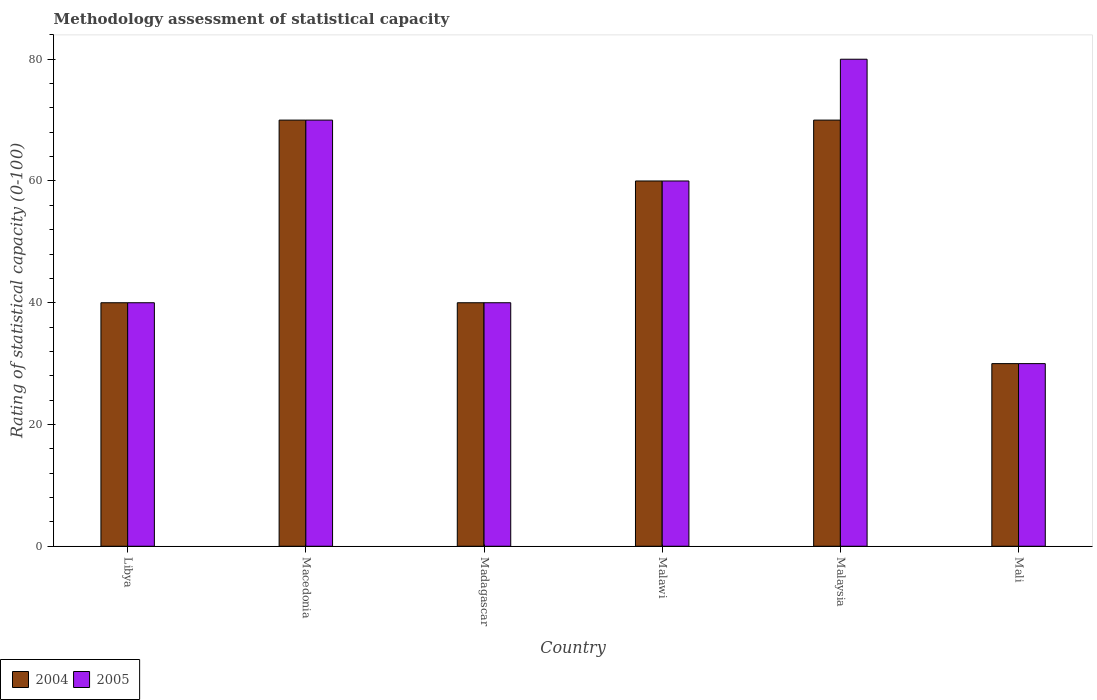How many different coloured bars are there?
Your answer should be very brief. 2. How many groups of bars are there?
Keep it short and to the point. 6. Are the number of bars on each tick of the X-axis equal?
Provide a short and direct response. Yes. What is the label of the 3rd group of bars from the left?
Offer a very short reply. Madagascar. In how many cases, is the number of bars for a given country not equal to the number of legend labels?
Make the answer very short. 0. What is the rating of statistical capacity in 2005 in Libya?
Keep it short and to the point. 40. Across all countries, what is the maximum rating of statistical capacity in 2004?
Your answer should be very brief. 70. In which country was the rating of statistical capacity in 2005 maximum?
Offer a very short reply. Malaysia. In which country was the rating of statistical capacity in 2004 minimum?
Your answer should be compact. Mali. What is the total rating of statistical capacity in 2004 in the graph?
Offer a terse response. 310. What is the difference between the rating of statistical capacity in 2004 in Libya and that in Malaysia?
Give a very brief answer. -30. What is the average rating of statistical capacity in 2004 per country?
Provide a short and direct response. 51.67. What is the difference between the rating of statistical capacity of/in 2004 and rating of statistical capacity of/in 2005 in Malawi?
Your answer should be compact. 0. In how many countries, is the rating of statistical capacity in 2004 greater than 56?
Provide a short and direct response. 3. What is the difference between the highest and the lowest rating of statistical capacity in 2004?
Your answer should be very brief. 40. What does the 2nd bar from the left in Libya represents?
Ensure brevity in your answer.  2005. What does the 1st bar from the right in Macedonia represents?
Your answer should be compact. 2005. Are all the bars in the graph horizontal?
Make the answer very short. No. What is the difference between two consecutive major ticks on the Y-axis?
Give a very brief answer. 20. What is the title of the graph?
Give a very brief answer. Methodology assessment of statistical capacity. Does "2012" appear as one of the legend labels in the graph?
Your response must be concise. No. What is the label or title of the X-axis?
Give a very brief answer. Country. What is the label or title of the Y-axis?
Provide a succinct answer. Rating of statistical capacity (0-100). What is the Rating of statistical capacity (0-100) of 2005 in Libya?
Make the answer very short. 40. What is the Rating of statistical capacity (0-100) of 2004 in Macedonia?
Your answer should be very brief. 70. What is the Rating of statistical capacity (0-100) in 2004 in Madagascar?
Give a very brief answer. 40. What is the Rating of statistical capacity (0-100) of 2005 in Madagascar?
Provide a succinct answer. 40. What is the Rating of statistical capacity (0-100) in 2004 in Malawi?
Your response must be concise. 60. What is the Rating of statistical capacity (0-100) in 2005 in Malawi?
Make the answer very short. 60. What is the Rating of statistical capacity (0-100) in 2004 in Mali?
Offer a terse response. 30. Across all countries, what is the maximum Rating of statistical capacity (0-100) in 2004?
Keep it short and to the point. 70. Across all countries, what is the minimum Rating of statistical capacity (0-100) of 2005?
Offer a very short reply. 30. What is the total Rating of statistical capacity (0-100) of 2004 in the graph?
Provide a short and direct response. 310. What is the total Rating of statistical capacity (0-100) in 2005 in the graph?
Offer a very short reply. 320. What is the difference between the Rating of statistical capacity (0-100) in 2004 in Libya and that in Madagascar?
Your answer should be compact. 0. What is the difference between the Rating of statistical capacity (0-100) in 2004 in Libya and that in Malawi?
Ensure brevity in your answer.  -20. What is the difference between the Rating of statistical capacity (0-100) of 2005 in Libya and that in Malawi?
Give a very brief answer. -20. What is the difference between the Rating of statistical capacity (0-100) in 2005 in Libya and that in Mali?
Your answer should be compact. 10. What is the difference between the Rating of statistical capacity (0-100) in 2004 in Macedonia and that in Madagascar?
Make the answer very short. 30. What is the difference between the Rating of statistical capacity (0-100) in 2005 in Macedonia and that in Madagascar?
Keep it short and to the point. 30. What is the difference between the Rating of statistical capacity (0-100) in 2004 in Macedonia and that in Malawi?
Provide a short and direct response. 10. What is the difference between the Rating of statistical capacity (0-100) of 2005 in Macedonia and that in Malawi?
Give a very brief answer. 10. What is the difference between the Rating of statistical capacity (0-100) of 2004 in Macedonia and that in Malaysia?
Ensure brevity in your answer.  0. What is the difference between the Rating of statistical capacity (0-100) of 2005 in Macedonia and that in Malaysia?
Give a very brief answer. -10. What is the difference between the Rating of statistical capacity (0-100) of 2004 in Macedonia and that in Mali?
Offer a terse response. 40. What is the difference between the Rating of statistical capacity (0-100) of 2005 in Macedonia and that in Mali?
Your response must be concise. 40. What is the difference between the Rating of statistical capacity (0-100) in 2004 in Madagascar and that in Malawi?
Your response must be concise. -20. What is the difference between the Rating of statistical capacity (0-100) in 2004 in Madagascar and that in Malaysia?
Your answer should be compact. -30. What is the difference between the Rating of statistical capacity (0-100) in 2004 in Malawi and that in Malaysia?
Offer a terse response. -10. What is the difference between the Rating of statistical capacity (0-100) of 2005 in Malawi and that in Malaysia?
Make the answer very short. -20. What is the difference between the Rating of statistical capacity (0-100) of 2005 in Malawi and that in Mali?
Ensure brevity in your answer.  30. What is the difference between the Rating of statistical capacity (0-100) in 2004 in Malaysia and that in Mali?
Give a very brief answer. 40. What is the difference between the Rating of statistical capacity (0-100) in 2004 in Macedonia and the Rating of statistical capacity (0-100) in 2005 in Madagascar?
Give a very brief answer. 30. What is the difference between the Rating of statistical capacity (0-100) in 2004 in Macedonia and the Rating of statistical capacity (0-100) in 2005 in Malawi?
Offer a very short reply. 10. What is the difference between the Rating of statistical capacity (0-100) in 2004 in Malawi and the Rating of statistical capacity (0-100) in 2005 in Mali?
Your response must be concise. 30. What is the average Rating of statistical capacity (0-100) in 2004 per country?
Ensure brevity in your answer.  51.67. What is the average Rating of statistical capacity (0-100) of 2005 per country?
Ensure brevity in your answer.  53.33. What is the difference between the Rating of statistical capacity (0-100) in 2004 and Rating of statistical capacity (0-100) in 2005 in Macedonia?
Provide a short and direct response. 0. What is the difference between the Rating of statistical capacity (0-100) of 2004 and Rating of statistical capacity (0-100) of 2005 in Malawi?
Your response must be concise. 0. What is the difference between the Rating of statistical capacity (0-100) of 2004 and Rating of statistical capacity (0-100) of 2005 in Mali?
Your answer should be very brief. 0. What is the ratio of the Rating of statistical capacity (0-100) in 2004 in Libya to that in Macedonia?
Offer a terse response. 0.57. What is the ratio of the Rating of statistical capacity (0-100) in 2005 in Libya to that in Macedonia?
Your answer should be compact. 0.57. What is the ratio of the Rating of statistical capacity (0-100) of 2005 in Libya to that in Madagascar?
Keep it short and to the point. 1. What is the ratio of the Rating of statistical capacity (0-100) of 2004 in Libya to that in Malawi?
Your answer should be compact. 0.67. What is the ratio of the Rating of statistical capacity (0-100) in 2005 in Libya to that in Malawi?
Provide a succinct answer. 0.67. What is the ratio of the Rating of statistical capacity (0-100) of 2004 in Libya to that in Malaysia?
Provide a succinct answer. 0.57. What is the ratio of the Rating of statistical capacity (0-100) of 2005 in Libya to that in Mali?
Ensure brevity in your answer.  1.33. What is the ratio of the Rating of statistical capacity (0-100) in 2004 in Macedonia to that in Madagascar?
Keep it short and to the point. 1.75. What is the ratio of the Rating of statistical capacity (0-100) in 2004 in Macedonia to that in Mali?
Ensure brevity in your answer.  2.33. What is the ratio of the Rating of statistical capacity (0-100) in 2005 in Macedonia to that in Mali?
Keep it short and to the point. 2.33. What is the ratio of the Rating of statistical capacity (0-100) in 2004 in Madagascar to that in Malawi?
Ensure brevity in your answer.  0.67. What is the ratio of the Rating of statistical capacity (0-100) of 2005 in Madagascar to that in Malawi?
Keep it short and to the point. 0.67. What is the ratio of the Rating of statistical capacity (0-100) in 2004 in Madagascar to that in Malaysia?
Your response must be concise. 0.57. What is the ratio of the Rating of statistical capacity (0-100) of 2004 in Malawi to that in Malaysia?
Provide a short and direct response. 0.86. What is the ratio of the Rating of statistical capacity (0-100) in 2004 in Malawi to that in Mali?
Provide a succinct answer. 2. What is the ratio of the Rating of statistical capacity (0-100) in 2004 in Malaysia to that in Mali?
Make the answer very short. 2.33. What is the ratio of the Rating of statistical capacity (0-100) of 2005 in Malaysia to that in Mali?
Offer a very short reply. 2.67. What is the difference between the highest and the second highest Rating of statistical capacity (0-100) in 2004?
Provide a succinct answer. 0. What is the difference between the highest and the second highest Rating of statistical capacity (0-100) of 2005?
Offer a terse response. 10. What is the difference between the highest and the lowest Rating of statistical capacity (0-100) of 2005?
Provide a succinct answer. 50. 